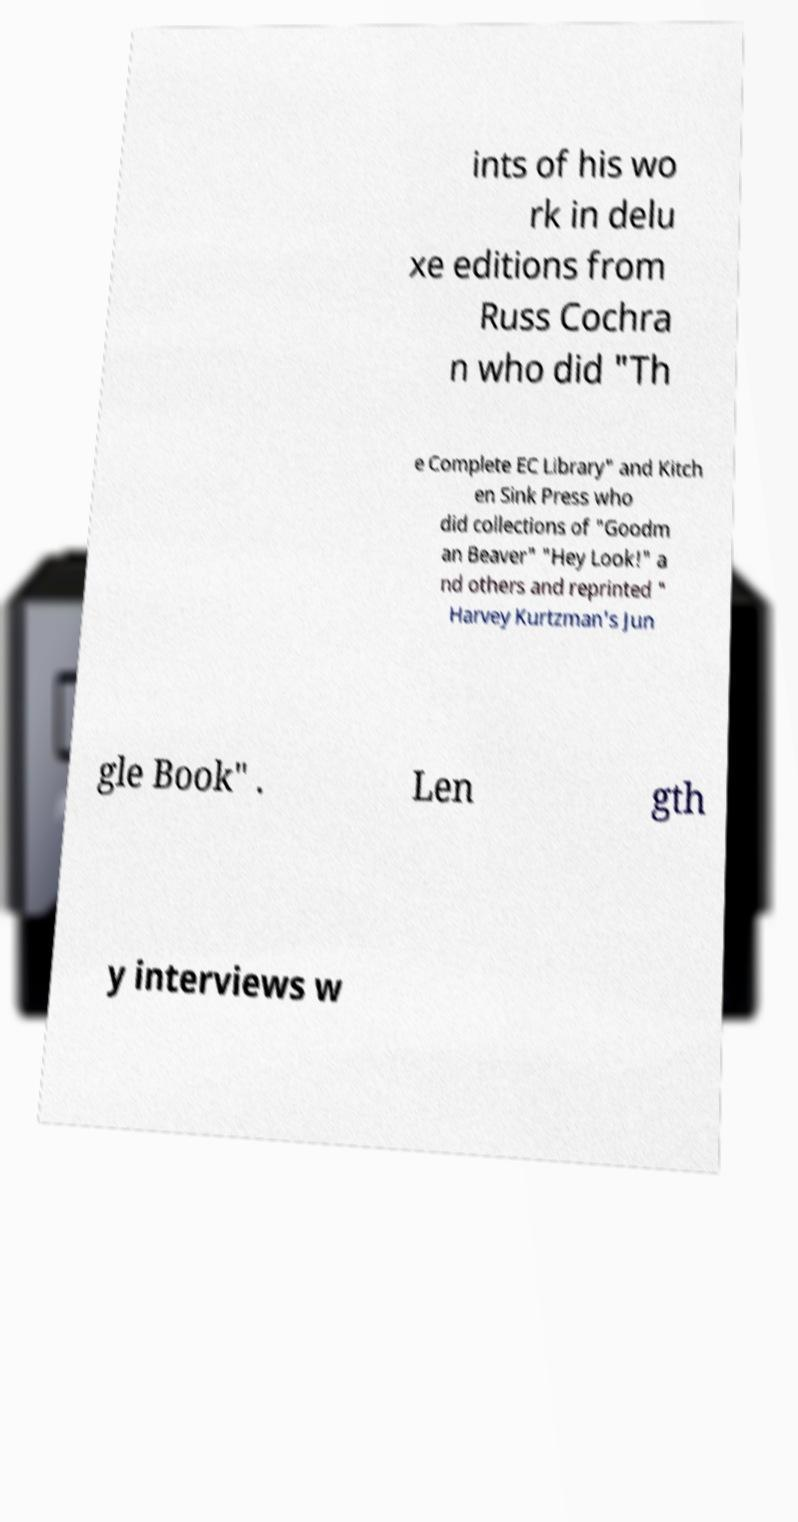Could you assist in decoding the text presented in this image and type it out clearly? ints of his wo rk in delu xe editions from Russ Cochra n who did "Th e Complete EC Library" and Kitch en Sink Press who did collections of "Goodm an Beaver" "Hey Look!" a nd others and reprinted " Harvey Kurtzman's Jun gle Book" . Len gth y interviews w 